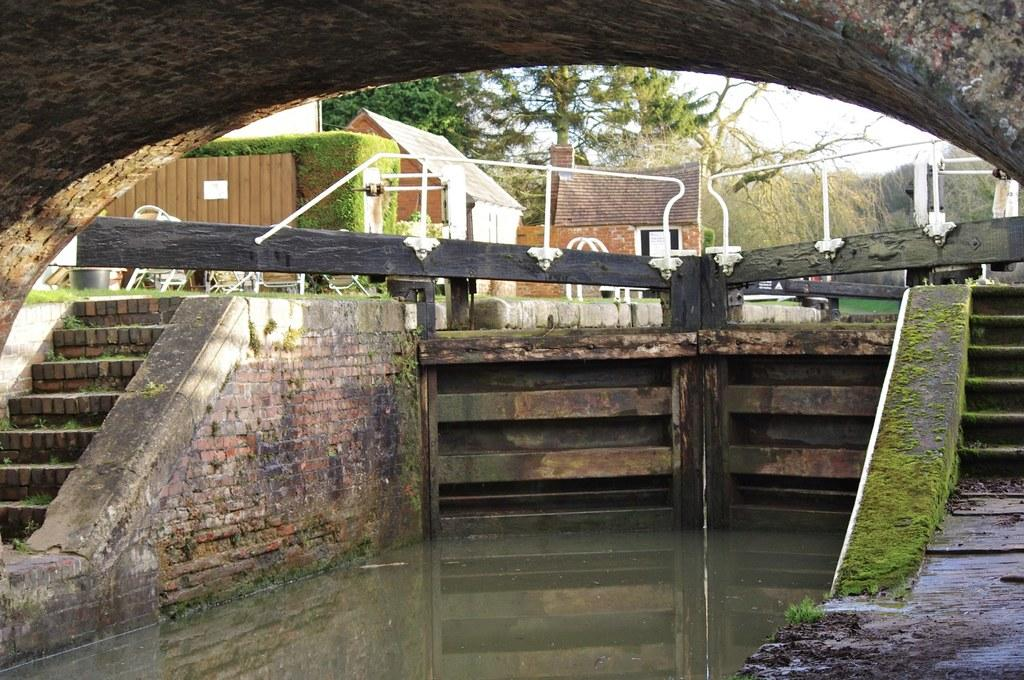What is the primary element in the image? There is water in the image. What architectural feature is present on both sides of the water? There are stairs on both sides of the water. What type of furniture can be seen in the image? There are chairs visible in the image. What can be seen in the distance in the image? There are houses in the background of the image. What type of vegetation is present in the image? Trees are present in the image. What safety feature is present in the image? There is a railing in the image. What is the color of the sky in the image? The sky appears to be white in color. How many worms can be seen crawling on the chairs in the image? There are no worms present in the image; only chairs, water, stairs, houses, trees, a railing, and a white sky are visible. 